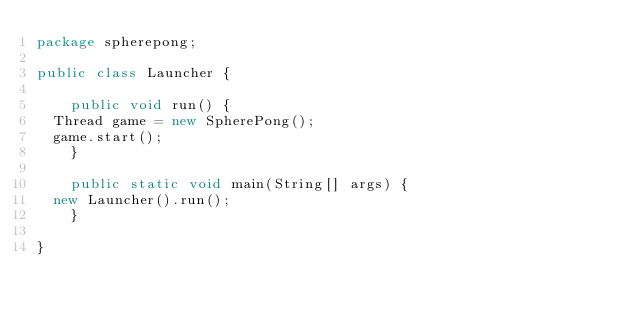<code> <loc_0><loc_0><loc_500><loc_500><_Java_>package spherepong;

public class Launcher {
        
    public void run() {
	Thread game = new SpherePong();
	game.start();
    }

    public static void main(String[] args) {
	new Launcher().run();
    }

}
</code> 